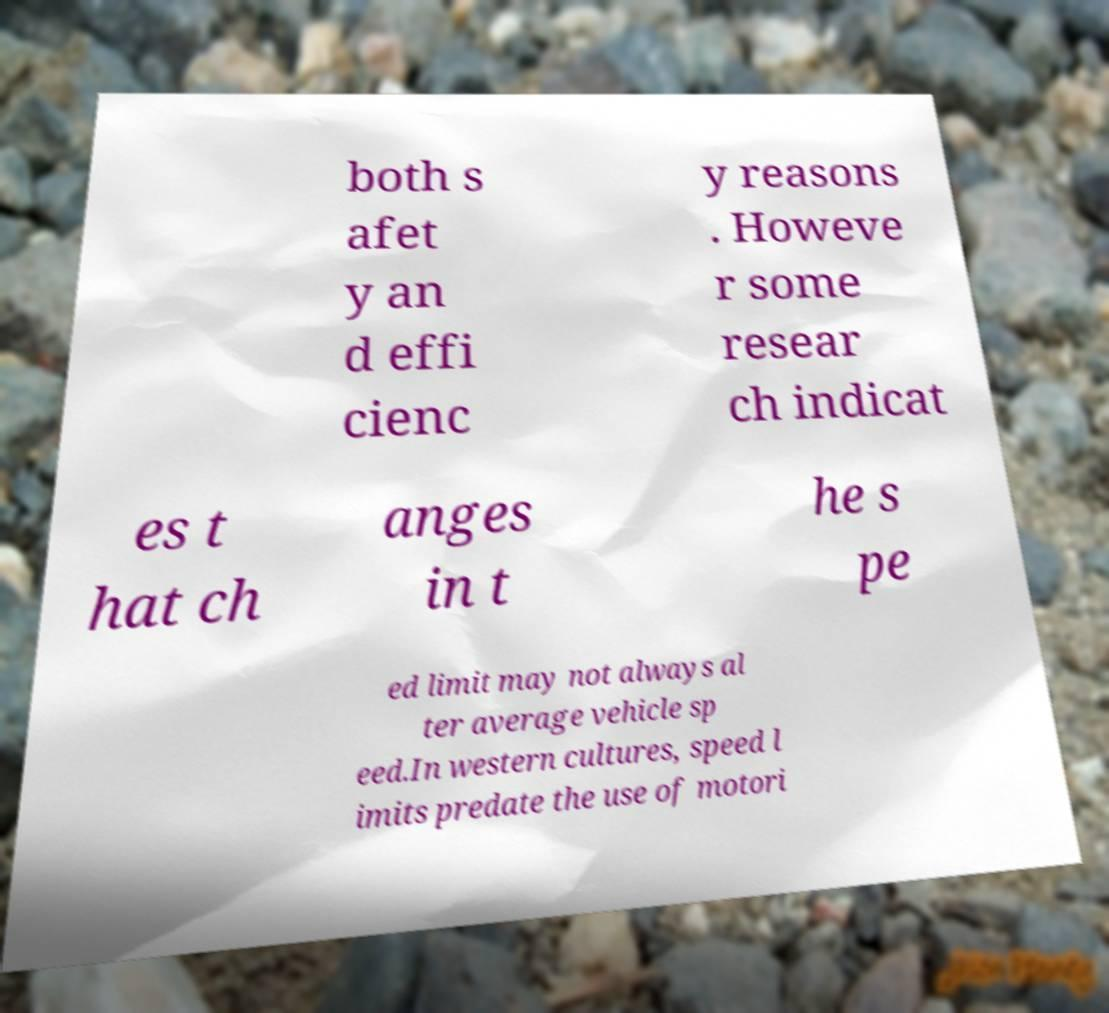Please read and relay the text visible in this image. What does it say? both s afet y an d effi cienc y reasons . Howeve r some resear ch indicat es t hat ch anges in t he s pe ed limit may not always al ter average vehicle sp eed.In western cultures, speed l imits predate the use of motori 